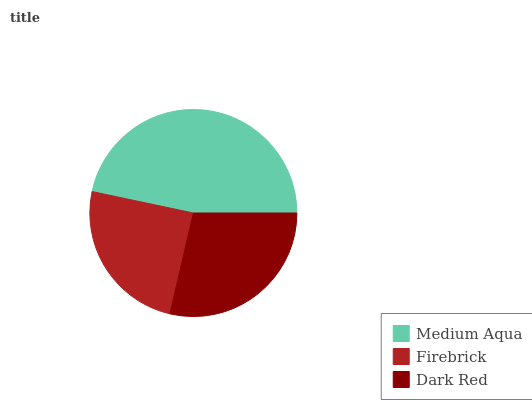Is Firebrick the minimum?
Answer yes or no. Yes. Is Medium Aqua the maximum?
Answer yes or no. Yes. Is Dark Red the minimum?
Answer yes or no. No. Is Dark Red the maximum?
Answer yes or no. No. Is Dark Red greater than Firebrick?
Answer yes or no. Yes. Is Firebrick less than Dark Red?
Answer yes or no. Yes. Is Firebrick greater than Dark Red?
Answer yes or no. No. Is Dark Red less than Firebrick?
Answer yes or no. No. Is Dark Red the high median?
Answer yes or no. Yes. Is Dark Red the low median?
Answer yes or no. Yes. Is Firebrick the high median?
Answer yes or no. No. Is Medium Aqua the low median?
Answer yes or no. No. 